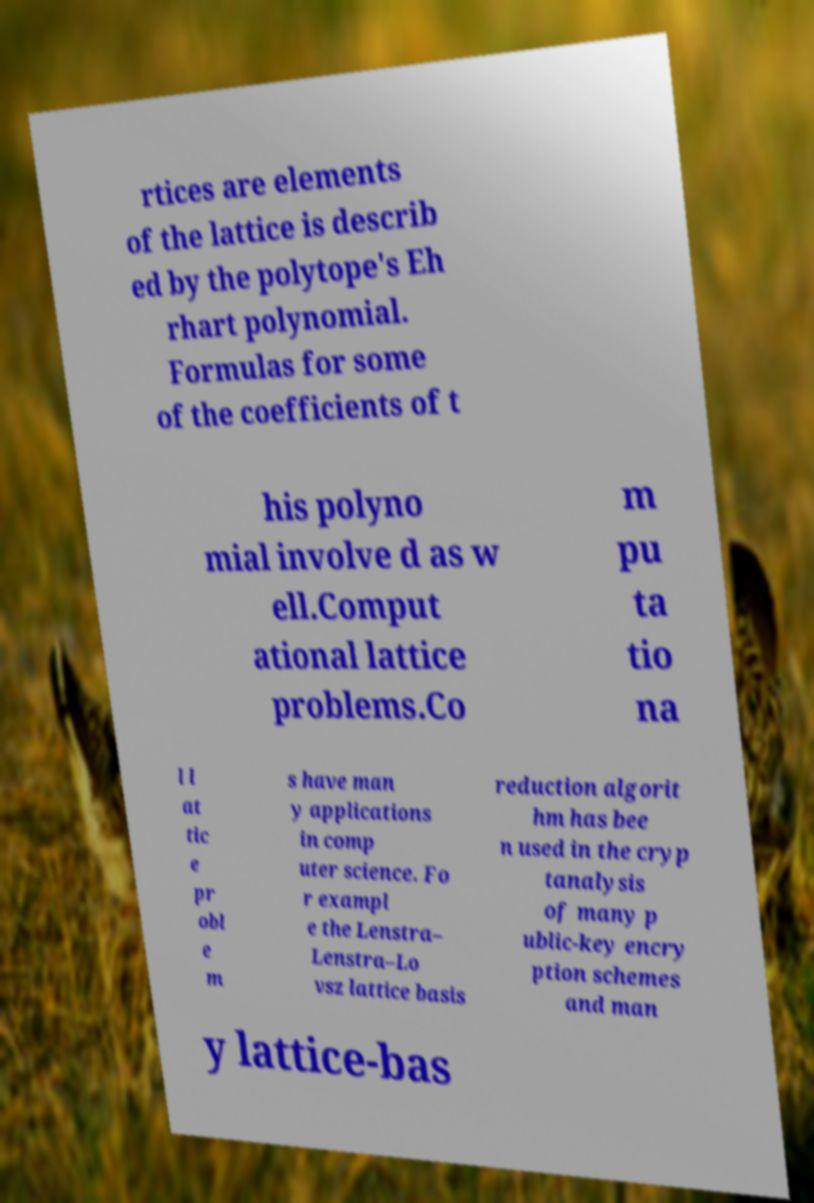Could you assist in decoding the text presented in this image and type it out clearly? rtices are elements of the lattice is describ ed by the polytope's Eh rhart polynomial. Formulas for some of the coefficients of t his polyno mial involve d as w ell.Comput ational lattice problems.Co m pu ta tio na l l at tic e pr obl e m s have man y applications in comp uter science. Fo r exampl e the Lenstra– Lenstra–Lo vsz lattice basis reduction algorit hm has bee n used in the cryp tanalysis of many p ublic-key encry ption schemes and man y lattice-bas 